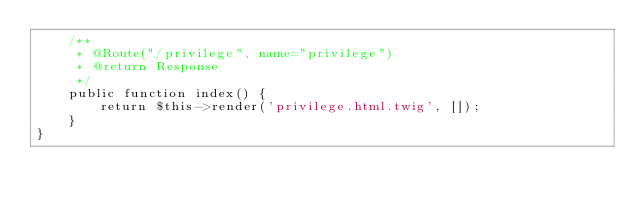<code> <loc_0><loc_0><loc_500><loc_500><_PHP_>    /**
     * @Route("/privilege", name="privilege")
     * @return Response
     */
    public function index() {
        return $this->render('privilege.html.twig', []);
    }
}</code> 